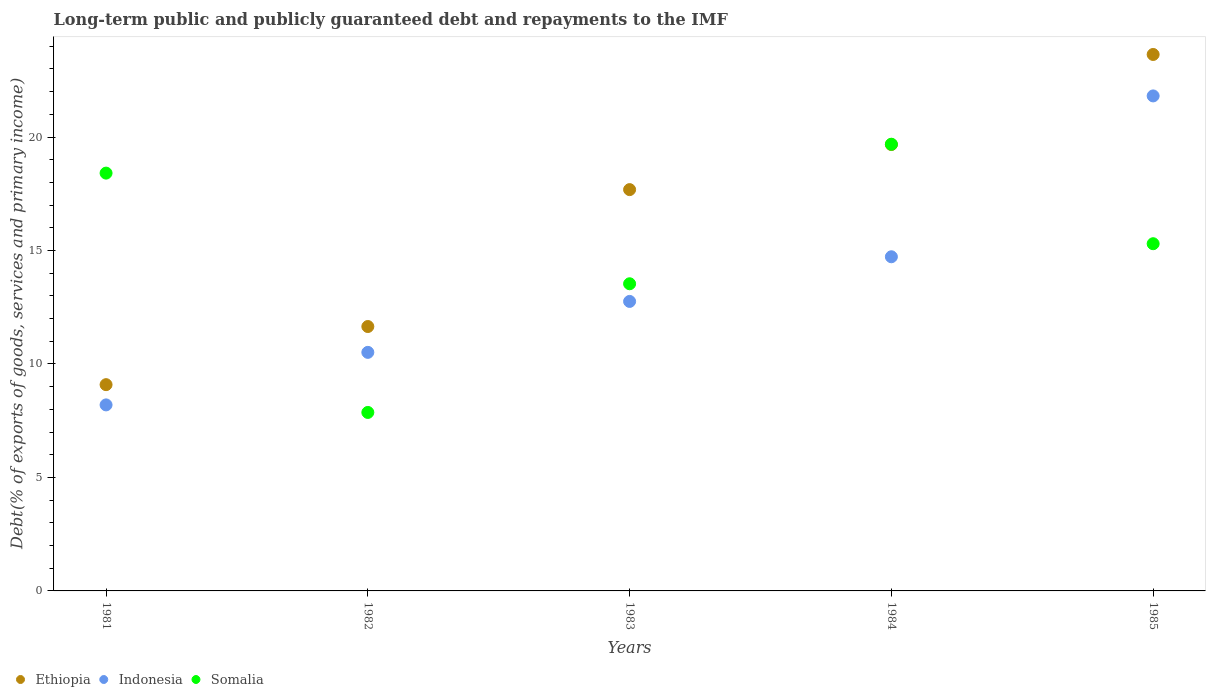How many different coloured dotlines are there?
Offer a terse response. 3. Is the number of dotlines equal to the number of legend labels?
Your answer should be compact. Yes. What is the debt and repayments in Indonesia in 1985?
Your response must be concise. 21.81. Across all years, what is the maximum debt and repayments in Somalia?
Offer a very short reply. 19.68. Across all years, what is the minimum debt and repayments in Somalia?
Provide a short and direct response. 7.86. In which year was the debt and repayments in Ethiopia maximum?
Your response must be concise. 1985. In which year was the debt and repayments in Somalia minimum?
Your answer should be compact. 1982. What is the total debt and repayments in Somalia in the graph?
Keep it short and to the point. 74.79. What is the difference between the debt and repayments in Ethiopia in 1981 and that in 1982?
Offer a very short reply. -2.56. What is the difference between the debt and repayments in Somalia in 1985 and the debt and repayments in Ethiopia in 1983?
Provide a succinct answer. -2.38. What is the average debt and repayments in Ethiopia per year?
Offer a terse response. 16.34. In the year 1982, what is the difference between the debt and repayments in Somalia and debt and repayments in Ethiopia?
Keep it short and to the point. -3.79. In how many years, is the debt and repayments in Indonesia greater than 10 %?
Your answer should be very brief. 4. What is the ratio of the debt and repayments in Indonesia in 1981 to that in 1983?
Provide a succinct answer. 0.64. Is the debt and repayments in Somalia in 1982 less than that in 1984?
Offer a terse response. Yes. Is the difference between the debt and repayments in Somalia in 1982 and 1983 greater than the difference between the debt and repayments in Ethiopia in 1982 and 1983?
Make the answer very short. Yes. What is the difference between the highest and the second highest debt and repayments in Indonesia?
Offer a terse response. 7.09. What is the difference between the highest and the lowest debt and repayments in Somalia?
Your answer should be compact. 11.82. Does the debt and repayments in Ethiopia monotonically increase over the years?
Provide a short and direct response. Yes. Is the debt and repayments in Indonesia strictly less than the debt and repayments in Ethiopia over the years?
Keep it short and to the point. Yes. How many years are there in the graph?
Your answer should be very brief. 5. Are the values on the major ticks of Y-axis written in scientific E-notation?
Make the answer very short. No. How are the legend labels stacked?
Ensure brevity in your answer.  Horizontal. What is the title of the graph?
Give a very brief answer. Long-term public and publicly guaranteed debt and repayments to the IMF. Does "India" appear as one of the legend labels in the graph?
Give a very brief answer. No. What is the label or title of the X-axis?
Provide a short and direct response. Years. What is the label or title of the Y-axis?
Provide a succinct answer. Debt(% of exports of goods, services and primary income). What is the Debt(% of exports of goods, services and primary income) in Ethiopia in 1981?
Make the answer very short. 9.09. What is the Debt(% of exports of goods, services and primary income) in Indonesia in 1981?
Your answer should be very brief. 8.2. What is the Debt(% of exports of goods, services and primary income) of Somalia in 1981?
Make the answer very short. 18.41. What is the Debt(% of exports of goods, services and primary income) of Ethiopia in 1982?
Your answer should be very brief. 11.65. What is the Debt(% of exports of goods, services and primary income) of Indonesia in 1982?
Offer a very short reply. 10.51. What is the Debt(% of exports of goods, services and primary income) of Somalia in 1982?
Provide a succinct answer. 7.86. What is the Debt(% of exports of goods, services and primary income) of Ethiopia in 1983?
Make the answer very short. 17.68. What is the Debt(% of exports of goods, services and primary income) of Indonesia in 1983?
Your answer should be compact. 12.76. What is the Debt(% of exports of goods, services and primary income) of Somalia in 1983?
Your answer should be very brief. 13.53. What is the Debt(% of exports of goods, services and primary income) of Ethiopia in 1984?
Keep it short and to the point. 19.67. What is the Debt(% of exports of goods, services and primary income) of Indonesia in 1984?
Your response must be concise. 14.72. What is the Debt(% of exports of goods, services and primary income) of Somalia in 1984?
Provide a short and direct response. 19.68. What is the Debt(% of exports of goods, services and primary income) of Ethiopia in 1985?
Give a very brief answer. 23.64. What is the Debt(% of exports of goods, services and primary income) in Indonesia in 1985?
Provide a succinct answer. 21.81. What is the Debt(% of exports of goods, services and primary income) in Somalia in 1985?
Your answer should be compact. 15.3. Across all years, what is the maximum Debt(% of exports of goods, services and primary income) of Ethiopia?
Offer a terse response. 23.64. Across all years, what is the maximum Debt(% of exports of goods, services and primary income) of Indonesia?
Your response must be concise. 21.81. Across all years, what is the maximum Debt(% of exports of goods, services and primary income) in Somalia?
Your answer should be very brief. 19.68. Across all years, what is the minimum Debt(% of exports of goods, services and primary income) in Ethiopia?
Offer a terse response. 9.09. Across all years, what is the minimum Debt(% of exports of goods, services and primary income) in Indonesia?
Your answer should be compact. 8.2. Across all years, what is the minimum Debt(% of exports of goods, services and primary income) in Somalia?
Make the answer very short. 7.86. What is the total Debt(% of exports of goods, services and primary income) in Ethiopia in the graph?
Make the answer very short. 81.72. What is the total Debt(% of exports of goods, services and primary income) of Indonesia in the graph?
Your response must be concise. 68. What is the total Debt(% of exports of goods, services and primary income) of Somalia in the graph?
Make the answer very short. 74.79. What is the difference between the Debt(% of exports of goods, services and primary income) in Ethiopia in 1981 and that in 1982?
Offer a terse response. -2.56. What is the difference between the Debt(% of exports of goods, services and primary income) of Indonesia in 1981 and that in 1982?
Offer a very short reply. -2.31. What is the difference between the Debt(% of exports of goods, services and primary income) in Somalia in 1981 and that in 1982?
Your answer should be compact. 10.54. What is the difference between the Debt(% of exports of goods, services and primary income) in Ethiopia in 1981 and that in 1983?
Provide a short and direct response. -8.59. What is the difference between the Debt(% of exports of goods, services and primary income) of Indonesia in 1981 and that in 1983?
Your response must be concise. -4.56. What is the difference between the Debt(% of exports of goods, services and primary income) in Somalia in 1981 and that in 1983?
Offer a very short reply. 4.88. What is the difference between the Debt(% of exports of goods, services and primary income) in Ethiopia in 1981 and that in 1984?
Make the answer very short. -10.58. What is the difference between the Debt(% of exports of goods, services and primary income) of Indonesia in 1981 and that in 1984?
Offer a terse response. -6.53. What is the difference between the Debt(% of exports of goods, services and primary income) in Somalia in 1981 and that in 1984?
Keep it short and to the point. -1.27. What is the difference between the Debt(% of exports of goods, services and primary income) of Ethiopia in 1981 and that in 1985?
Give a very brief answer. -14.55. What is the difference between the Debt(% of exports of goods, services and primary income) of Indonesia in 1981 and that in 1985?
Your answer should be very brief. -13.61. What is the difference between the Debt(% of exports of goods, services and primary income) of Somalia in 1981 and that in 1985?
Make the answer very short. 3.11. What is the difference between the Debt(% of exports of goods, services and primary income) in Ethiopia in 1982 and that in 1983?
Offer a very short reply. -6.03. What is the difference between the Debt(% of exports of goods, services and primary income) of Indonesia in 1982 and that in 1983?
Give a very brief answer. -2.24. What is the difference between the Debt(% of exports of goods, services and primary income) of Somalia in 1982 and that in 1983?
Provide a succinct answer. -5.67. What is the difference between the Debt(% of exports of goods, services and primary income) of Ethiopia in 1982 and that in 1984?
Your response must be concise. -8.02. What is the difference between the Debt(% of exports of goods, services and primary income) in Indonesia in 1982 and that in 1984?
Your answer should be compact. -4.21. What is the difference between the Debt(% of exports of goods, services and primary income) of Somalia in 1982 and that in 1984?
Offer a terse response. -11.82. What is the difference between the Debt(% of exports of goods, services and primary income) in Ethiopia in 1982 and that in 1985?
Provide a succinct answer. -11.99. What is the difference between the Debt(% of exports of goods, services and primary income) in Indonesia in 1982 and that in 1985?
Your response must be concise. -11.3. What is the difference between the Debt(% of exports of goods, services and primary income) of Somalia in 1982 and that in 1985?
Your answer should be very brief. -7.43. What is the difference between the Debt(% of exports of goods, services and primary income) of Ethiopia in 1983 and that in 1984?
Offer a terse response. -1.99. What is the difference between the Debt(% of exports of goods, services and primary income) in Indonesia in 1983 and that in 1984?
Provide a succinct answer. -1.97. What is the difference between the Debt(% of exports of goods, services and primary income) of Somalia in 1983 and that in 1984?
Give a very brief answer. -6.15. What is the difference between the Debt(% of exports of goods, services and primary income) of Ethiopia in 1983 and that in 1985?
Offer a terse response. -5.95. What is the difference between the Debt(% of exports of goods, services and primary income) of Indonesia in 1983 and that in 1985?
Provide a short and direct response. -9.05. What is the difference between the Debt(% of exports of goods, services and primary income) of Somalia in 1983 and that in 1985?
Offer a very short reply. -1.76. What is the difference between the Debt(% of exports of goods, services and primary income) of Ethiopia in 1984 and that in 1985?
Provide a short and direct response. -3.97. What is the difference between the Debt(% of exports of goods, services and primary income) of Indonesia in 1984 and that in 1985?
Provide a short and direct response. -7.09. What is the difference between the Debt(% of exports of goods, services and primary income) in Somalia in 1984 and that in 1985?
Provide a short and direct response. 4.38. What is the difference between the Debt(% of exports of goods, services and primary income) of Ethiopia in 1981 and the Debt(% of exports of goods, services and primary income) of Indonesia in 1982?
Your response must be concise. -1.42. What is the difference between the Debt(% of exports of goods, services and primary income) in Ethiopia in 1981 and the Debt(% of exports of goods, services and primary income) in Somalia in 1982?
Make the answer very short. 1.22. What is the difference between the Debt(% of exports of goods, services and primary income) of Indonesia in 1981 and the Debt(% of exports of goods, services and primary income) of Somalia in 1982?
Give a very brief answer. 0.33. What is the difference between the Debt(% of exports of goods, services and primary income) in Ethiopia in 1981 and the Debt(% of exports of goods, services and primary income) in Indonesia in 1983?
Give a very brief answer. -3.67. What is the difference between the Debt(% of exports of goods, services and primary income) of Ethiopia in 1981 and the Debt(% of exports of goods, services and primary income) of Somalia in 1983?
Provide a succinct answer. -4.45. What is the difference between the Debt(% of exports of goods, services and primary income) of Indonesia in 1981 and the Debt(% of exports of goods, services and primary income) of Somalia in 1983?
Ensure brevity in your answer.  -5.34. What is the difference between the Debt(% of exports of goods, services and primary income) of Ethiopia in 1981 and the Debt(% of exports of goods, services and primary income) of Indonesia in 1984?
Your answer should be very brief. -5.63. What is the difference between the Debt(% of exports of goods, services and primary income) of Ethiopia in 1981 and the Debt(% of exports of goods, services and primary income) of Somalia in 1984?
Make the answer very short. -10.59. What is the difference between the Debt(% of exports of goods, services and primary income) of Indonesia in 1981 and the Debt(% of exports of goods, services and primary income) of Somalia in 1984?
Your answer should be compact. -11.49. What is the difference between the Debt(% of exports of goods, services and primary income) of Ethiopia in 1981 and the Debt(% of exports of goods, services and primary income) of Indonesia in 1985?
Make the answer very short. -12.72. What is the difference between the Debt(% of exports of goods, services and primary income) in Ethiopia in 1981 and the Debt(% of exports of goods, services and primary income) in Somalia in 1985?
Make the answer very short. -6.21. What is the difference between the Debt(% of exports of goods, services and primary income) in Indonesia in 1981 and the Debt(% of exports of goods, services and primary income) in Somalia in 1985?
Give a very brief answer. -7.1. What is the difference between the Debt(% of exports of goods, services and primary income) in Ethiopia in 1982 and the Debt(% of exports of goods, services and primary income) in Indonesia in 1983?
Your answer should be compact. -1.11. What is the difference between the Debt(% of exports of goods, services and primary income) in Ethiopia in 1982 and the Debt(% of exports of goods, services and primary income) in Somalia in 1983?
Keep it short and to the point. -1.88. What is the difference between the Debt(% of exports of goods, services and primary income) of Indonesia in 1982 and the Debt(% of exports of goods, services and primary income) of Somalia in 1983?
Ensure brevity in your answer.  -3.02. What is the difference between the Debt(% of exports of goods, services and primary income) in Ethiopia in 1982 and the Debt(% of exports of goods, services and primary income) in Indonesia in 1984?
Offer a terse response. -3.07. What is the difference between the Debt(% of exports of goods, services and primary income) of Ethiopia in 1982 and the Debt(% of exports of goods, services and primary income) of Somalia in 1984?
Provide a succinct answer. -8.03. What is the difference between the Debt(% of exports of goods, services and primary income) of Indonesia in 1982 and the Debt(% of exports of goods, services and primary income) of Somalia in 1984?
Make the answer very short. -9.17. What is the difference between the Debt(% of exports of goods, services and primary income) of Ethiopia in 1982 and the Debt(% of exports of goods, services and primary income) of Indonesia in 1985?
Ensure brevity in your answer.  -10.16. What is the difference between the Debt(% of exports of goods, services and primary income) in Ethiopia in 1982 and the Debt(% of exports of goods, services and primary income) in Somalia in 1985?
Make the answer very short. -3.65. What is the difference between the Debt(% of exports of goods, services and primary income) in Indonesia in 1982 and the Debt(% of exports of goods, services and primary income) in Somalia in 1985?
Your answer should be compact. -4.79. What is the difference between the Debt(% of exports of goods, services and primary income) of Ethiopia in 1983 and the Debt(% of exports of goods, services and primary income) of Indonesia in 1984?
Give a very brief answer. 2.96. What is the difference between the Debt(% of exports of goods, services and primary income) in Ethiopia in 1983 and the Debt(% of exports of goods, services and primary income) in Somalia in 1984?
Ensure brevity in your answer.  -2. What is the difference between the Debt(% of exports of goods, services and primary income) in Indonesia in 1983 and the Debt(% of exports of goods, services and primary income) in Somalia in 1984?
Your answer should be very brief. -6.93. What is the difference between the Debt(% of exports of goods, services and primary income) in Ethiopia in 1983 and the Debt(% of exports of goods, services and primary income) in Indonesia in 1985?
Provide a succinct answer. -4.13. What is the difference between the Debt(% of exports of goods, services and primary income) in Ethiopia in 1983 and the Debt(% of exports of goods, services and primary income) in Somalia in 1985?
Give a very brief answer. 2.38. What is the difference between the Debt(% of exports of goods, services and primary income) of Indonesia in 1983 and the Debt(% of exports of goods, services and primary income) of Somalia in 1985?
Provide a succinct answer. -2.54. What is the difference between the Debt(% of exports of goods, services and primary income) in Ethiopia in 1984 and the Debt(% of exports of goods, services and primary income) in Indonesia in 1985?
Offer a terse response. -2.14. What is the difference between the Debt(% of exports of goods, services and primary income) in Ethiopia in 1984 and the Debt(% of exports of goods, services and primary income) in Somalia in 1985?
Make the answer very short. 4.37. What is the difference between the Debt(% of exports of goods, services and primary income) in Indonesia in 1984 and the Debt(% of exports of goods, services and primary income) in Somalia in 1985?
Ensure brevity in your answer.  -0.57. What is the average Debt(% of exports of goods, services and primary income) in Ethiopia per year?
Your response must be concise. 16.34. What is the average Debt(% of exports of goods, services and primary income) of Indonesia per year?
Your answer should be compact. 13.6. What is the average Debt(% of exports of goods, services and primary income) of Somalia per year?
Ensure brevity in your answer.  14.96. In the year 1981, what is the difference between the Debt(% of exports of goods, services and primary income) of Ethiopia and Debt(% of exports of goods, services and primary income) of Indonesia?
Provide a short and direct response. 0.89. In the year 1981, what is the difference between the Debt(% of exports of goods, services and primary income) of Ethiopia and Debt(% of exports of goods, services and primary income) of Somalia?
Make the answer very short. -9.32. In the year 1981, what is the difference between the Debt(% of exports of goods, services and primary income) of Indonesia and Debt(% of exports of goods, services and primary income) of Somalia?
Provide a succinct answer. -10.21. In the year 1982, what is the difference between the Debt(% of exports of goods, services and primary income) in Ethiopia and Debt(% of exports of goods, services and primary income) in Indonesia?
Your response must be concise. 1.14. In the year 1982, what is the difference between the Debt(% of exports of goods, services and primary income) of Ethiopia and Debt(% of exports of goods, services and primary income) of Somalia?
Your answer should be compact. 3.79. In the year 1982, what is the difference between the Debt(% of exports of goods, services and primary income) in Indonesia and Debt(% of exports of goods, services and primary income) in Somalia?
Provide a short and direct response. 2.65. In the year 1983, what is the difference between the Debt(% of exports of goods, services and primary income) in Ethiopia and Debt(% of exports of goods, services and primary income) in Indonesia?
Keep it short and to the point. 4.93. In the year 1983, what is the difference between the Debt(% of exports of goods, services and primary income) of Ethiopia and Debt(% of exports of goods, services and primary income) of Somalia?
Provide a short and direct response. 4.15. In the year 1983, what is the difference between the Debt(% of exports of goods, services and primary income) in Indonesia and Debt(% of exports of goods, services and primary income) in Somalia?
Your answer should be compact. -0.78. In the year 1984, what is the difference between the Debt(% of exports of goods, services and primary income) in Ethiopia and Debt(% of exports of goods, services and primary income) in Indonesia?
Offer a very short reply. 4.94. In the year 1984, what is the difference between the Debt(% of exports of goods, services and primary income) of Ethiopia and Debt(% of exports of goods, services and primary income) of Somalia?
Your response must be concise. -0.01. In the year 1984, what is the difference between the Debt(% of exports of goods, services and primary income) of Indonesia and Debt(% of exports of goods, services and primary income) of Somalia?
Your answer should be compact. -4.96. In the year 1985, what is the difference between the Debt(% of exports of goods, services and primary income) of Ethiopia and Debt(% of exports of goods, services and primary income) of Indonesia?
Ensure brevity in your answer.  1.83. In the year 1985, what is the difference between the Debt(% of exports of goods, services and primary income) in Ethiopia and Debt(% of exports of goods, services and primary income) in Somalia?
Ensure brevity in your answer.  8.34. In the year 1985, what is the difference between the Debt(% of exports of goods, services and primary income) of Indonesia and Debt(% of exports of goods, services and primary income) of Somalia?
Your answer should be compact. 6.51. What is the ratio of the Debt(% of exports of goods, services and primary income) in Ethiopia in 1981 to that in 1982?
Ensure brevity in your answer.  0.78. What is the ratio of the Debt(% of exports of goods, services and primary income) in Indonesia in 1981 to that in 1982?
Provide a short and direct response. 0.78. What is the ratio of the Debt(% of exports of goods, services and primary income) in Somalia in 1981 to that in 1982?
Offer a terse response. 2.34. What is the ratio of the Debt(% of exports of goods, services and primary income) of Ethiopia in 1981 to that in 1983?
Your answer should be very brief. 0.51. What is the ratio of the Debt(% of exports of goods, services and primary income) in Indonesia in 1981 to that in 1983?
Make the answer very short. 0.64. What is the ratio of the Debt(% of exports of goods, services and primary income) in Somalia in 1981 to that in 1983?
Your answer should be compact. 1.36. What is the ratio of the Debt(% of exports of goods, services and primary income) in Ethiopia in 1981 to that in 1984?
Provide a succinct answer. 0.46. What is the ratio of the Debt(% of exports of goods, services and primary income) in Indonesia in 1981 to that in 1984?
Your response must be concise. 0.56. What is the ratio of the Debt(% of exports of goods, services and primary income) in Somalia in 1981 to that in 1984?
Give a very brief answer. 0.94. What is the ratio of the Debt(% of exports of goods, services and primary income) of Ethiopia in 1981 to that in 1985?
Offer a terse response. 0.38. What is the ratio of the Debt(% of exports of goods, services and primary income) in Indonesia in 1981 to that in 1985?
Your answer should be compact. 0.38. What is the ratio of the Debt(% of exports of goods, services and primary income) of Somalia in 1981 to that in 1985?
Give a very brief answer. 1.2. What is the ratio of the Debt(% of exports of goods, services and primary income) of Ethiopia in 1982 to that in 1983?
Your answer should be very brief. 0.66. What is the ratio of the Debt(% of exports of goods, services and primary income) in Indonesia in 1982 to that in 1983?
Make the answer very short. 0.82. What is the ratio of the Debt(% of exports of goods, services and primary income) in Somalia in 1982 to that in 1983?
Ensure brevity in your answer.  0.58. What is the ratio of the Debt(% of exports of goods, services and primary income) of Ethiopia in 1982 to that in 1984?
Your response must be concise. 0.59. What is the ratio of the Debt(% of exports of goods, services and primary income) in Indonesia in 1982 to that in 1984?
Give a very brief answer. 0.71. What is the ratio of the Debt(% of exports of goods, services and primary income) of Somalia in 1982 to that in 1984?
Your answer should be compact. 0.4. What is the ratio of the Debt(% of exports of goods, services and primary income) in Ethiopia in 1982 to that in 1985?
Provide a succinct answer. 0.49. What is the ratio of the Debt(% of exports of goods, services and primary income) of Indonesia in 1982 to that in 1985?
Provide a succinct answer. 0.48. What is the ratio of the Debt(% of exports of goods, services and primary income) in Somalia in 1982 to that in 1985?
Your answer should be compact. 0.51. What is the ratio of the Debt(% of exports of goods, services and primary income) of Ethiopia in 1983 to that in 1984?
Offer a very short reply. 0.9. What is the ratio of the Debt(% of exports of goods, services and primary income) of Indonesia in 1983 to that in 1984?
Provide a succinct answer. 0.87. What is the ratio of the Debt(% of exports of goods, services and primary income) of Somalia in 1983 to that in 1984?
Give a very brief answer. 0.69. What is the ratio of the Debt(% of exports of goods, services and primary income) of Ethiopia in 1983 to that in 1985?
Offer a terse response. 0.75. What is the ratio of the Debt(% of exports of goods, services and primary income) of Indonesia in 1983 to that in 1985?
Offer a very short reply. 0.58. What is the ratio of the Debt(% of exports of goods, services and primary income) in Somalia in 1983 to that in 1985?
Your answer should be compact. 0.88. What is the ratio of the Debt(% of exports of goods, services and primary income) in Ethiopia in 1984 to that in 1985?
Give a very brief answer. 0.83. What is the ratio of the Debt(% of exports of goods, services and primary income) in Indonesia in 1984 to that in 1985?
Your answer should be very brief. 0.68. What is the ratio of the Debt(% of exports of goods, services and primary income) of Somalia in 1984 to that in 1985?
Make the answer very short. 1.29. What is the difference between the highest and the second highest Debt(% of exports of goods, services and primary income) of Ethiopia?
Provide a succinct answer. 3.97. What is the difference between the highest and the second highest Debt(% of exports of goods, services and primary income) of Indonesia?
Offer a terse response. 7.09. What is the difference between the highest and the second highest Debt(% of exports of goods, services and primary income) of Somalia?
Your answer should be compact. 1.27. What is the difference between the highest and the lowest Debt(% of exports of goods, services and primary income) of Ethiopia?
Offer a terse response. 14.55. What is the difference between the highest and the lowest Debt(% of exports of goods, services and primary income) in Indonesia?
Provide a short and direct response. 13.61. What is the difference between the highest and the lowest Debt(% of exports of goods, services and primary income) of Somalia?
Provide a succinct answer. 11.82. 